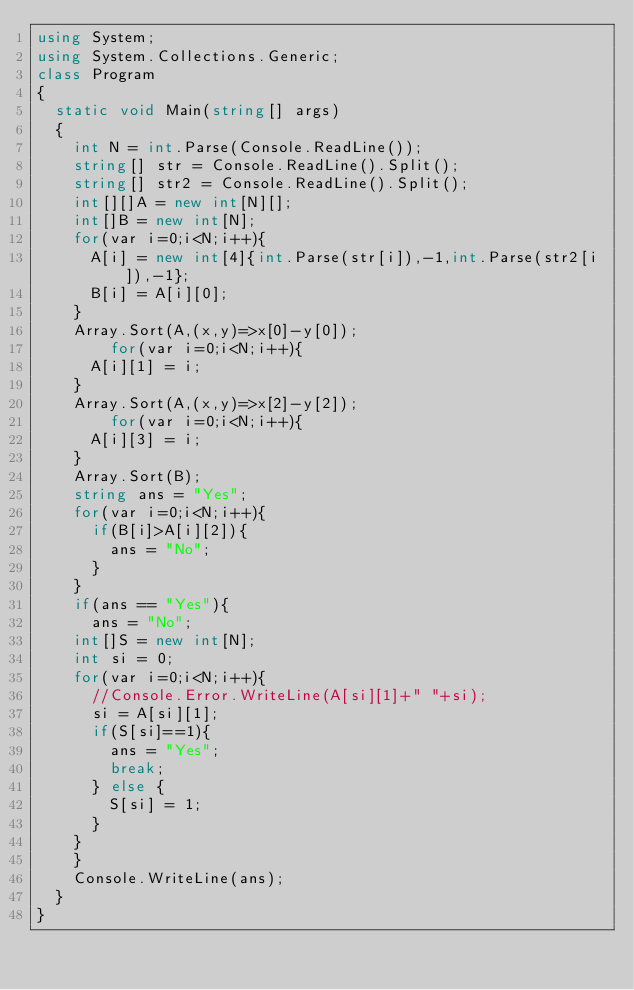<code> <loc_0><loc_0><loc_500><loc_500><_C#_>using System;
using System.Collections.Generic;
class Program
{
	static void Main(string[] args)
	{
		int N = int.Parse(Console.ReadLine());
		string[] str = Console.ReadLine().Split();
		string[] str2 = Console.ReadLine().Split();
		int[][]A = new int[N][];
		int[]B = new int[N];
		for(var i=0;i<N;i++){
			A[i] = new int[4]{int.Parse(str[i]),-1,int.Parse(str2[i]),-1};
			B[i] = A[i][0];
		}
		Array.Sort(A,(x,y)=>x[0]-y[0]);
      	for(var i=0;i<N;i++){
			A[i][1] = i;
		}
		Array.Sort(A,(x,y)=>x[2]-y[2]);
      	for(var i=0;i<N;i++){
			A[i][3] = i;
		}
		Array.Sort(B);
		string ans = "Yes";
		for(var i=0;i<N;i++){
			if(B[i]>A[i][2]){
				ans = "No";
			}
		}
		if(ans == "Yes"){
			ans = "No";
		int[]S = new int[N];
		int si = 0;
		for(var i=0;i<N;i++){
			//Console.Error.WriteLine(A[si][1]+" "+si);
			si = A[si][1];
			if(S[si]==1){
				ans = "Yes";
				break;
			} else {
				S[si] = 1;
			}
		}
		}
		Console.WriteLine(ans);
	}
}</code> 